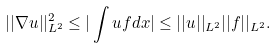Convert formula to latex. <formula><loc_0><loc_0><loc_500><loc_500>| | \nabla u | | _ { L ^ { 2 } } ^ { 2 } \leq | \int u f d x | \leq | | u | | _ { L ^ { 2 } } | | f | | _ { L ^ { 2 } } .</formula> 